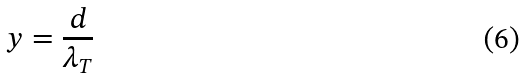<formula> <loc_0><loc_0><loc_500><loc_500>y = \frac { d } { \lambda _ { T } }</formula> 